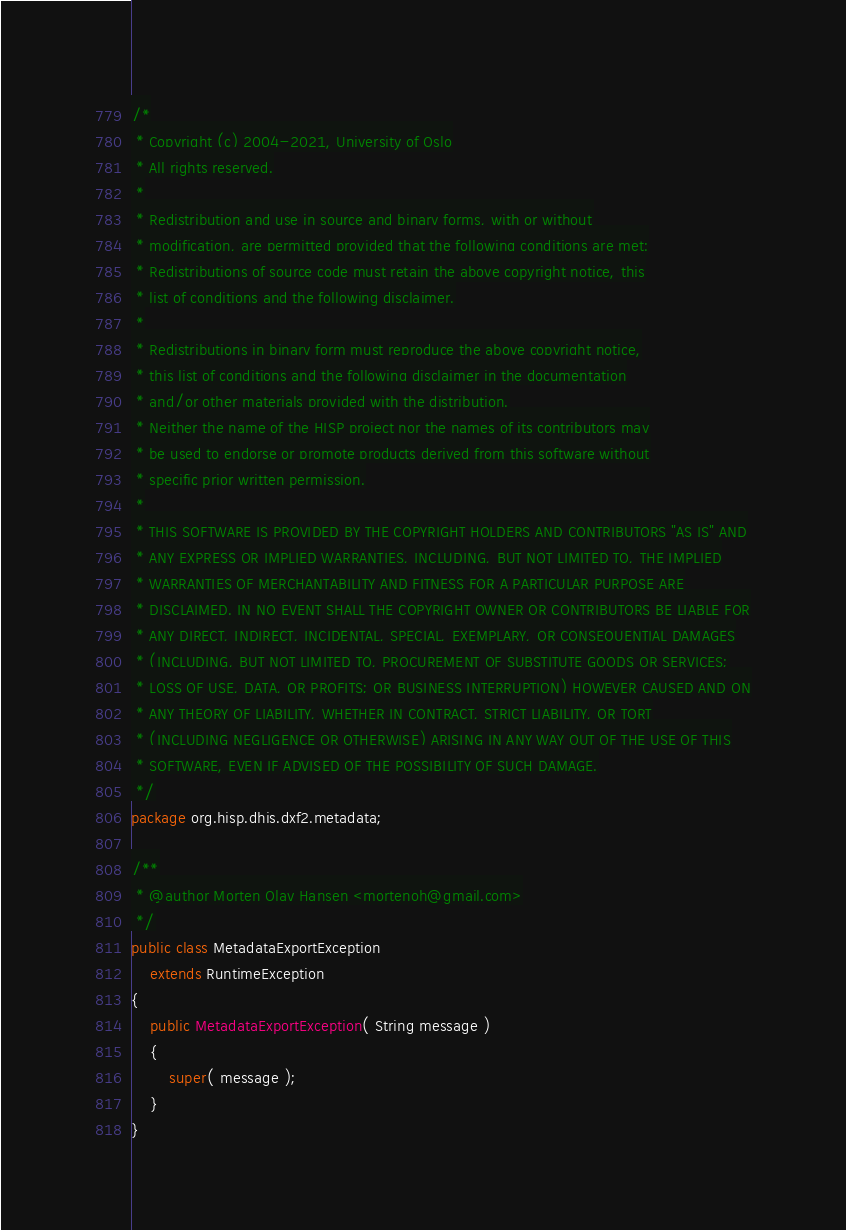Convert code to text. <code><loc_0><loc_0><loc_500><loc_500><_Java_>/*
 * Copyright (c) 2004-2021, University of Oslo
 * All rights reserved.
 *
 * Redistribution and use in source and binary forms, with or without
 * modification, are permitted provided that the following conditions are met:
 * Redistributions of source code must retain the above copyright notice, this
 * list of conditions and the following disclaimer.
 *
 * Redistributions in binary form must reproduce the above copyright notice,
 * this list of conditions and the following disclaimer in the documentation
 * and/or other materials provided with the distribution.
 * Neither the name of the HISP project nor the names of its contributors may
 * be used to endorse or promote products derived from this software without
 * specific prior written permission.
 *
 * THIS SOFTWARE IS PROVIDED BY THE COPYRIGHT HOLDERS AND CONTRIBUTORS "AS IS" AND
 * ANY EXPRESS OR IMPLIED WARRANTIES, INCLUDING, BUT NOT LIMITED TO, THE IMPLIED
 * WARRANTIES OF MERCHANTABILITY AND FITNESS FOR A PARTICULAR PURPOSE ARE
 * DISCLAIMED. IN NO EVENT SHALL THE COPYRIGHT OWNER OR CONTRIBUTORS BE LIABLE FOR
 * ANY DIRECT, INDIRECT, INCIDENTAL, SPECIAL, EXEMPLARY, OR CONSEQUENTIAL DAMAGES
 * (INCLUDING, BUT NOT LIMITED TO, PROCUREMENT OF SUBSTITUTE GOODS OR SERVICES;
 * LOSS OF USE, DATA, OR PROFITS; OR BUSINESS INTERRUPTION) HOWEVER CAUSED AND ON
 * ANY THEORY OF LIABILITY, WHETHER IN CONTRACT, STRICT LIABILITY, OR TORT
 * (INCLUDING NEGLIGENCE OR OTHERWISE) ARISING IN ANY WAY OUT OF THE USE OF THIS
 * SOFTWARE, EVEN IF ADVISED OF THE POSSIBILITY OF SUCH DAMAGE.
 */
package org.hisp.dhis.dxf2.metadata;

/**
 * @author Morten Olav Hansen <mortenoh@gmail.com>
 */
public class MetadataExportException
    extends RuntimeException
{
    public MetadataExportException( String message )
    {
        super( message );
    }
}
</code> 